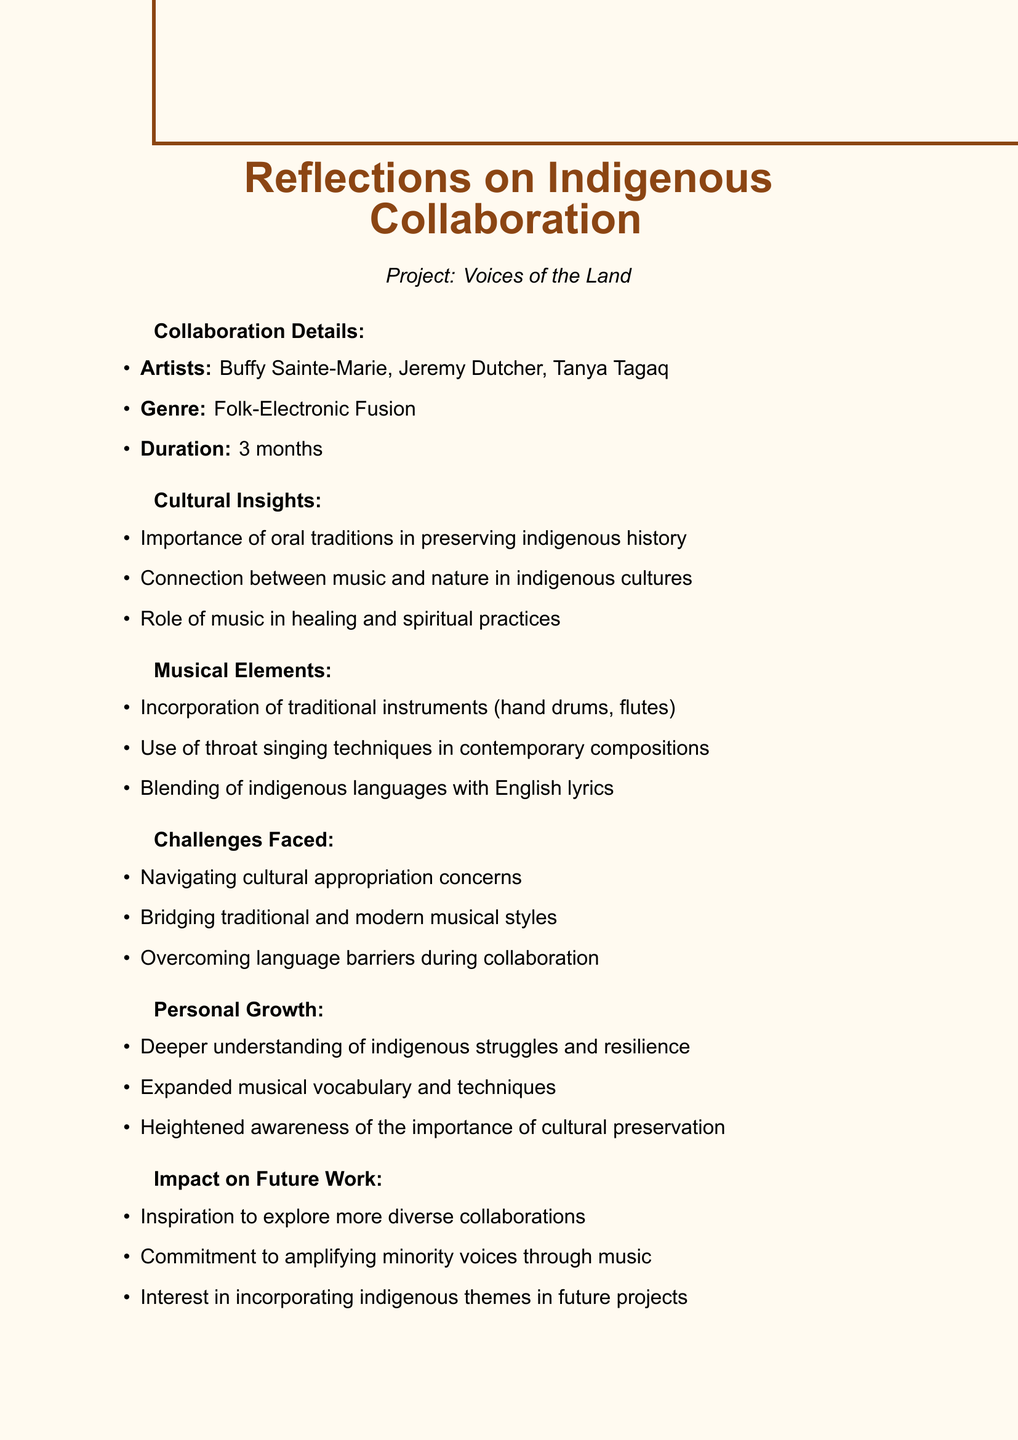What is the project name? The project name is clearly stated in the document as "Voices of the Land."
Answer: Voices of the Land Who are the indigenous artists involved? The document lists the artists involved as Buffy Sainte-Marie, Jeremy Dutcher, and Tanya Tagaq.
Answer: Buffy Sainte-Marie, Jeremy Dutcher, Tanya Tagaq What genre does the project belong to? The genre of the project is described as Folk-Electronic Fusion in the document.
Answer: Folk-Electronic Fusion What cultural insight emphasizes music's role in traditional practices? The document mentions the role of music in healing and spiritual practices as a cultural insight.
Answer: Healing and spiritual practices What major challenge involves ethical concerns in collaboration? One of the challenges faced during the collaboration is navigating cultural appropriation concerns.
Answer: Cultural appropriation concerns How long did the collaboration last? The duration of the collaboration is listed as 3 months in the document.
Answer: 3 months What personal growth was achieved regarding indigenous resilience? A deeper understanding of indigenous struggles and resilience was noted as personal growth.
Answer: Indigenous struggles and resilience What is one impact on future work mentioned in the document? One impact mentioned is the commitment to amplifying minority voices through music.
Answer: Amplifying minority voices through music Which traditional instruments were incorporated in the project? The document specifies that hand drums and flutes were traditional instruments incorporated.
Answer: Hand drums and flutes 